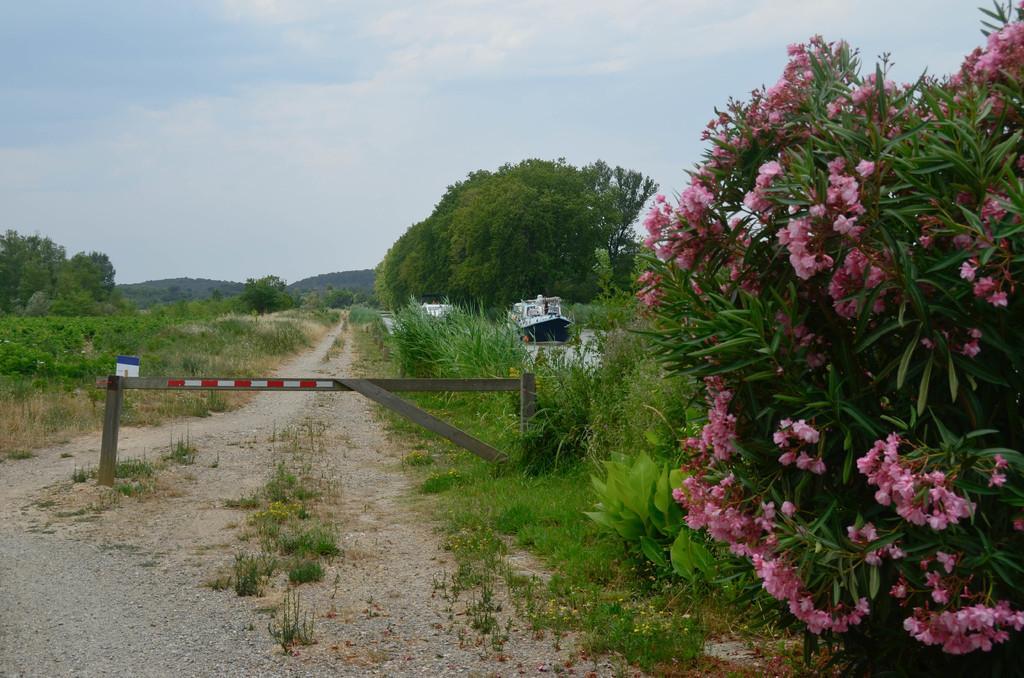How would you summarize this image in a sentence or two? This image is taken outdoors. At the bottom of the image there is a ground with grass on it. In the middle of the image there is an iron bar. In the background there are a few trees and plants and there are two ships. On the right side of the image there is a plant with beautiful pink colored flowers. At the top of the image there is a sky with clouds. 